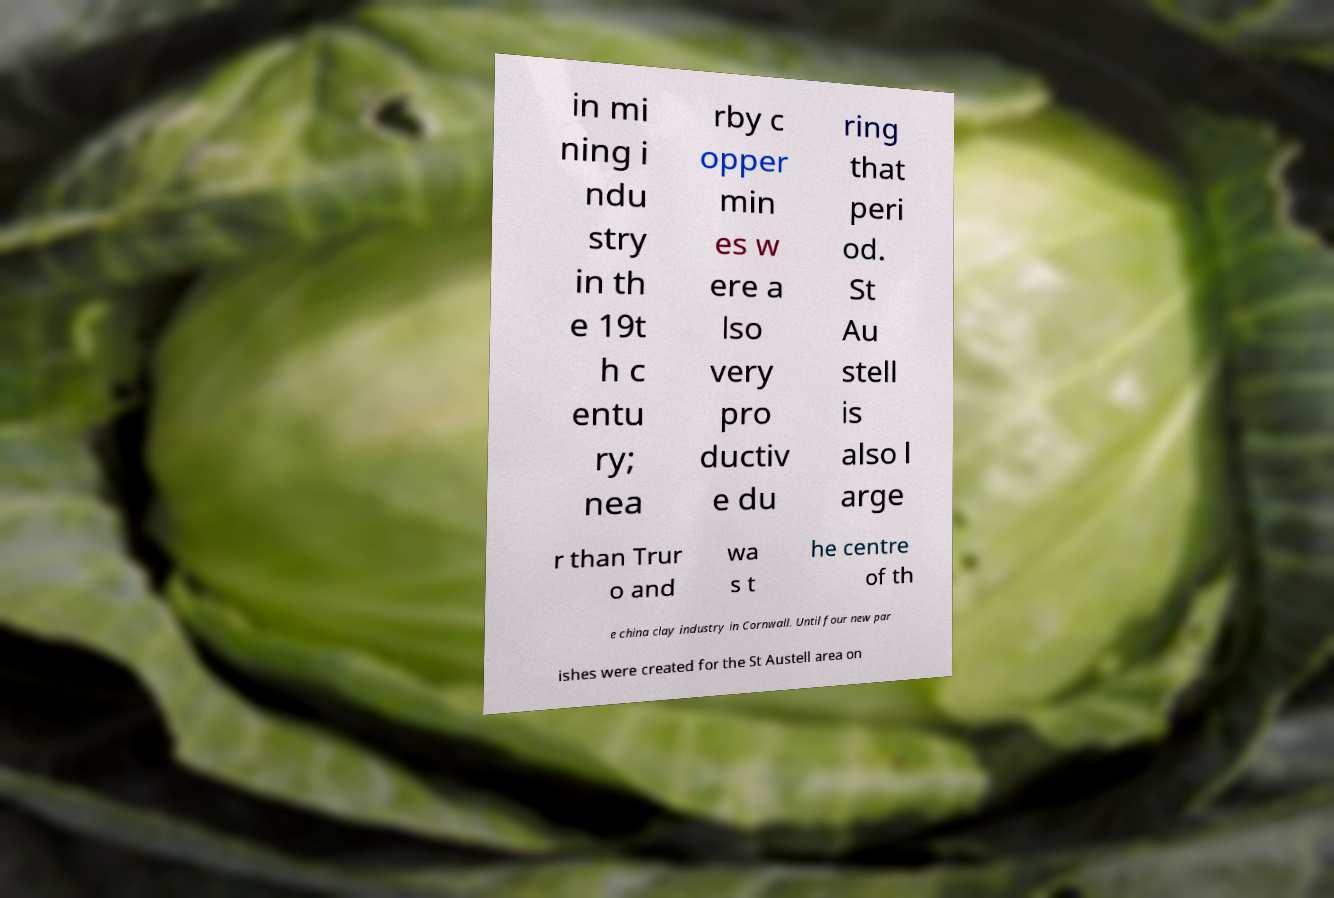Could you extract and type out the text from this image? in mi ning i ndu stry in th e 19t h c entu ry; nea rby c opper min es w ere a lso very pro ductiv e du ring that peri od. St Au stell is also l arge r than Trur o and wa s t he centre of th e china clay industry in Cornwall. Until four new par ishes were created for the St Austell area on 